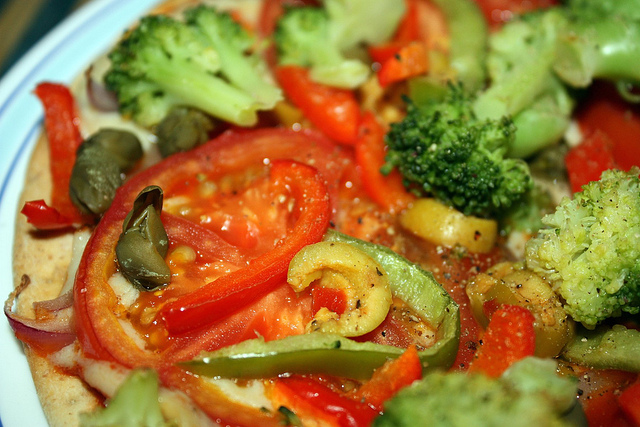What could be added to this meal to make it more protein-rich? To boost the protein content, you could consider adding grilled chicken strips, tofu, or legumes such as chickpeas or black beans. Sprinkling some cheese or seeds, like pumpkin or sunflower seeds, can also increase the protein value along with providing healthy fats. 